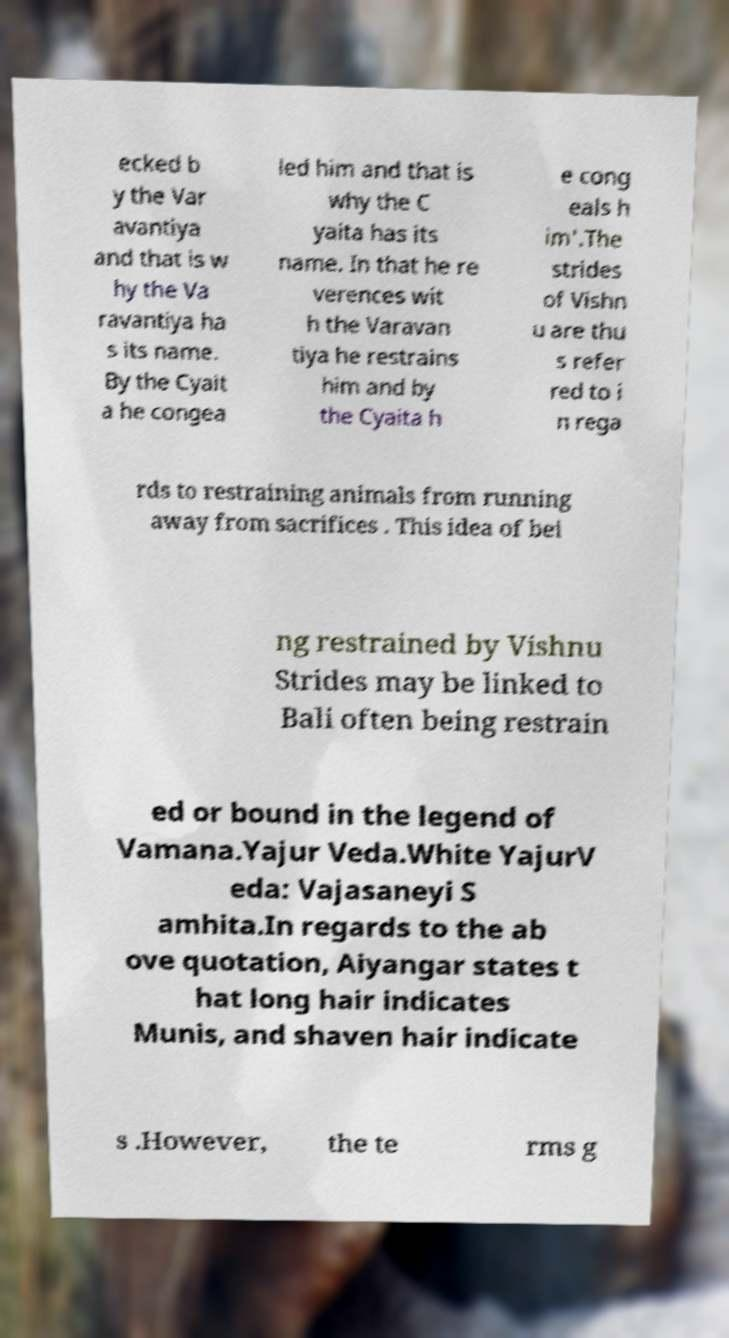What messages or text are displayed in this image? I need them in a readable, typed format. ecked b y the Var avantiya and that is w hy the Va ravantiya ha s its name. By the Cyait a he congea led him and that is why the C yaita has its name. In that he re verences wit h the Varavan tiya he restrains him and by the Cyaita h e cong eals h im'.The strides of Vishn u are thu s refer red to i n rega rds to restraining animals from running away from sacrifices . This idea of bei ng restrained by Vishnu Strides may be linked to Bali often being restrain ed or bound in the legend of Vamana.Yajur Veda.White YajurV eda: Vajasaneyi S amhita.In regards to the ab ove quotation, Aiyangar states t hat long hair indicates Munis, and shaven hair indicate s .However, the te rms g 